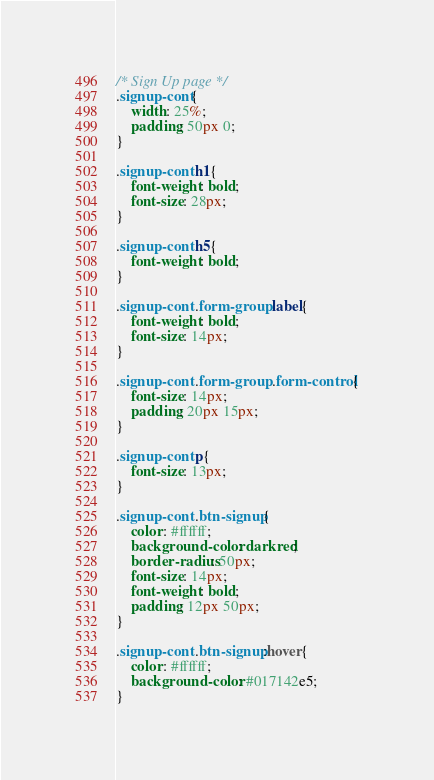Convert code to text. <code><loc_0><loc_0><loc_500><loc_500><_CSS_>/* Sign Up page */
.signup-cont{
    width: 25%;
    padding: 50px 0;
}

.signup-cont h1{
    font-weight: bold;
    font-size: 28px;
}

.signup-cont h5{
    font-weight: bold;
}

.signup-cont .form-group label{
    font-weight: bold;
    font-size: 14px;
}

.signup-cont .form-group .form-control{
    font-size: 14px;
    padding: 20px 15px;
}

.signup-cont p{
    font-size: 13px;
}

.signup-cont .btn-signup{
    color: #ffffff;
    background-color: darkred;
    border-radius: 50px;
    font-size: 14px;
    font-weight: bold;
    padding: 12px 50px;
}

.signup-cont .btn-signup:hover{
    color: #ffffff;
    background-color: #017142e5;
}</code> 